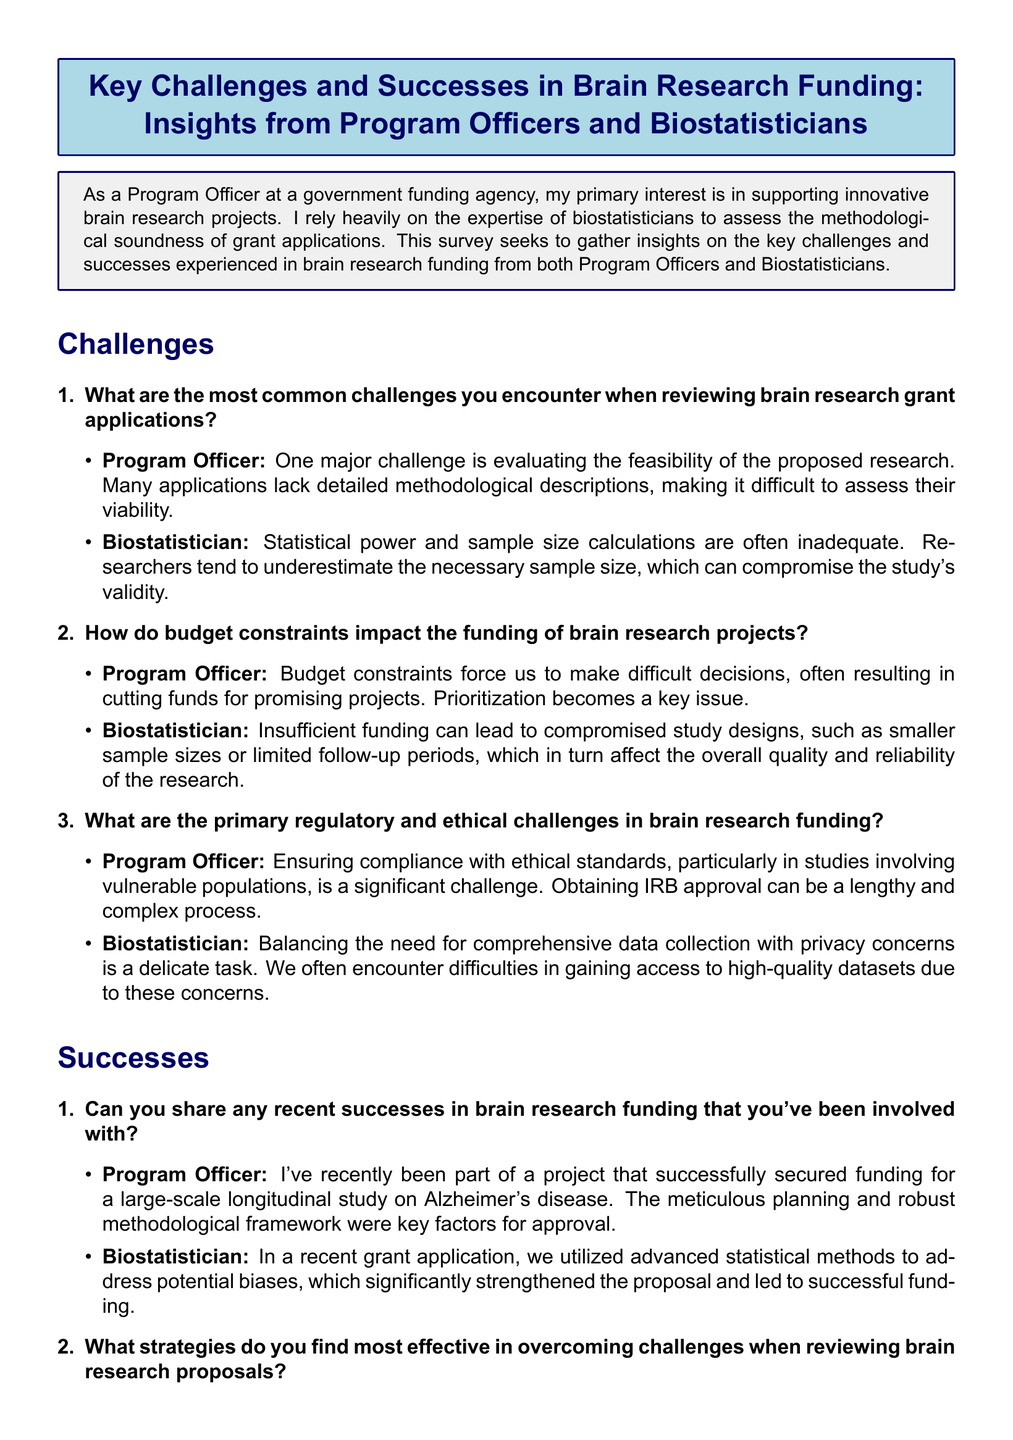What is the primary interest of the Program Officer? The primary interest of the Program Officer is in supporting innovative brain research projects, as stated in the introduction.
Answer: supporting innovative brain research projects What common challenge does the Program Officer face? One major challenge mentioned by the Program Officer is evaluating the feasibility of proposed research, due to a lack of detailed methodological descriptions.
Answer: evaluating feasibility What impact do budget constraints have according to the Program Officer? Budget constraints force the Program Officer to make difficult decisions, often resulting in cutting funds for promising projects.
Answer: cutting funds What is one strategy that the Biostatistician finds effective in overcoming challenges? The Biostatistician believes that early involvement in the grant writing process is an effective strategy to ensure better-designed studies.
Answer: early involvement How does the Program Officer measure the impact of funded projects? The Program Officer uses metrics such as publication counts and citation indices to measure the impact of funded projects.
Answer: publication counts What are the primary regulatory challenges mentioned by the Program Officer? The primary regulatory challenge mentioned is ensuring compliance with ethical standards, especially in studies involving vulnerable populations.
Answer: ethical standards compliance What contribution did advanced statistical methods make in recent grant applications? Advanced statistical methods significantly strengthened a grant proposal, leading to successful funding as noted by the Biostatistician.
Answer: successful funding What type of study was funded recently according to the Program Officer? The Program Officer mentions a large-scale longitudinal study on Alzheimer's disease that successfully secured funding.
Answer: longitudinal study on Alzheimer's disease 